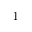<formula> <loc_0><loc_0><loc_500><loc_500>^ { - 1 }</formula> 